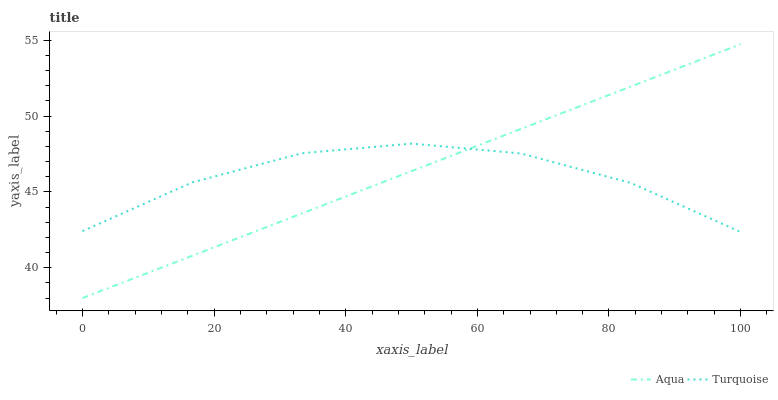Does Turquoise have the minimum area under the curve?
Answer yes or no. Yes. Does Aqua have the maximum area under the curve?
Answer yes or no. Yes. Does Aqua have the minimum area under the curve?
Answer yes or no. No. Is Aqua the smoothest?
Answer yes or no. Yes. Is Turquoise the roughest?
Answer yes or no. Yes. Is Aqua the roughest?
Answer yes or no. No. Does Aqua have the lowest value?
Answer yes or no. Yes. Does Aqua have the highest value?
Answer yes or no. Yes. Does Turquoise intersect Aqua?
Answer yes or no. Yes. Is Turquoise less than Aqua?
Answer yes or no. No. Is Turquoise greater than Aqua?
Answer yes or no. No. 